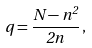<formula> <loc_0><loc_0><loc_500><loc_500>q = \frac { N - n ^ { 2 } } { 2 n } \, ,</formula> 